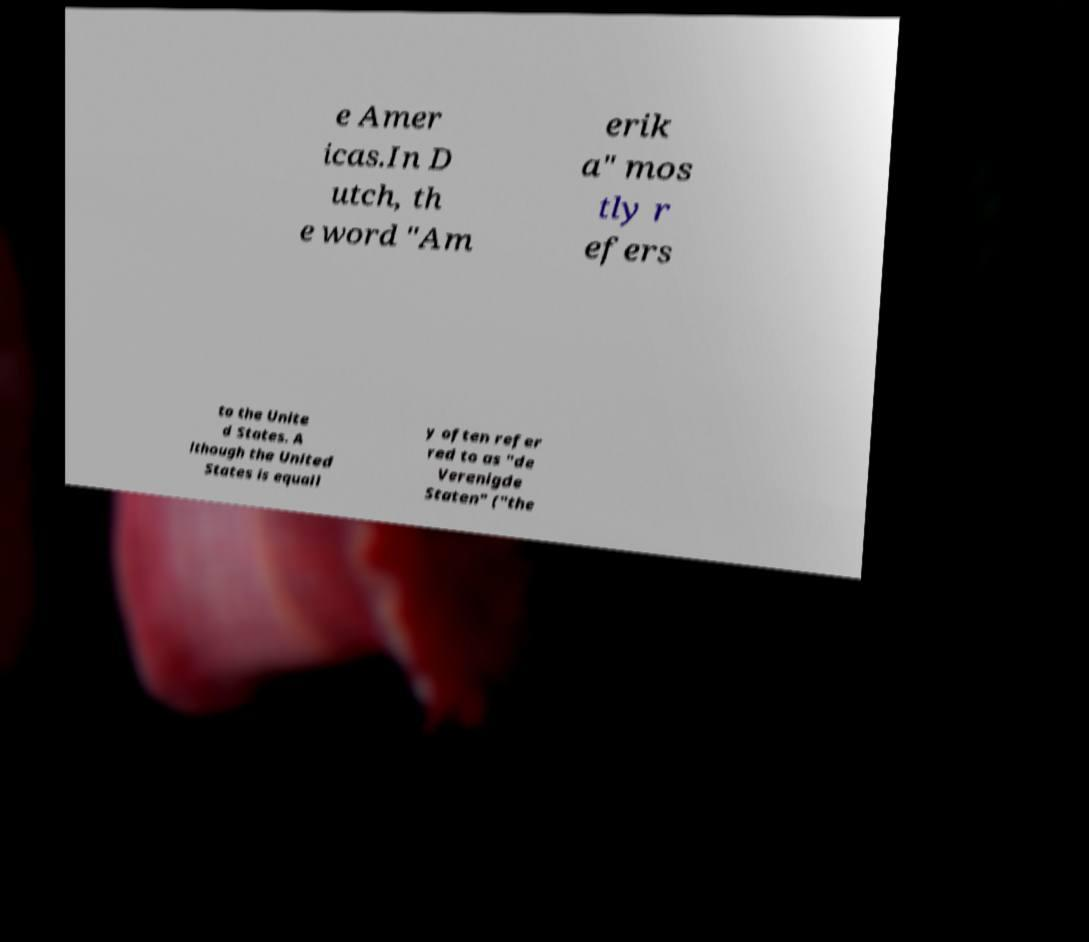Could you extract and type out the text from this image? e Amer icas.In D utch, th e word "Am erik a" mos tly r efers to the Unite d States. A lthough the United States is equall y often refer red to as "de Verenigde Staten" ("the 